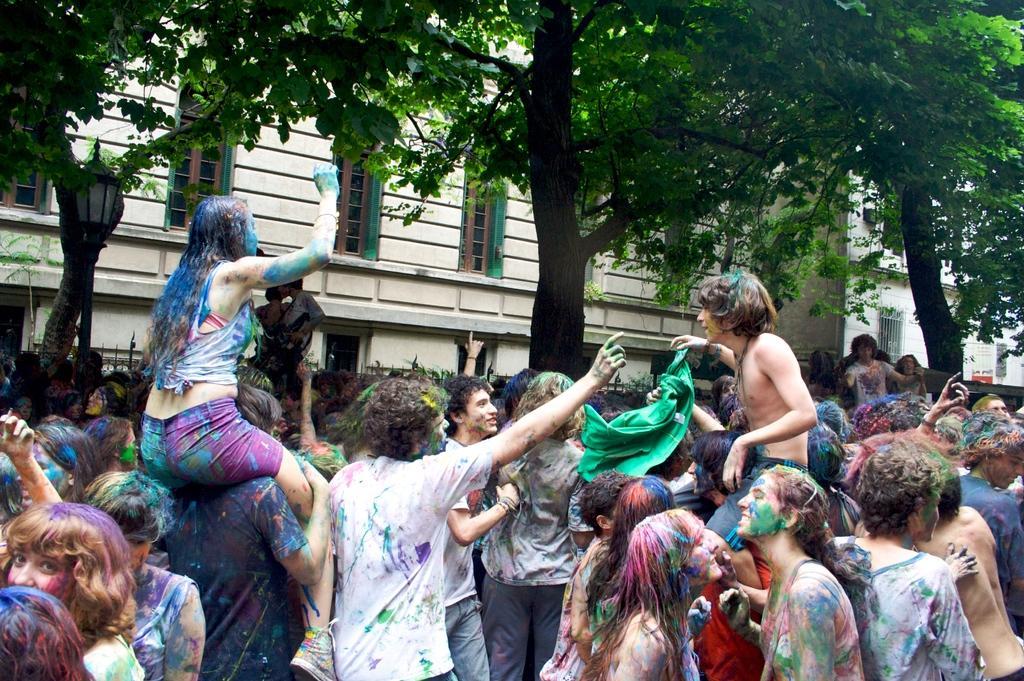In one or two sentences, can you explain what this image depicts? In this image I can see number of people are standing in the front. I can also see colours on their bodies and on their clothes. In the background I can see few trees, few buildings and on the left side of this image I can see a street light and a pole. 